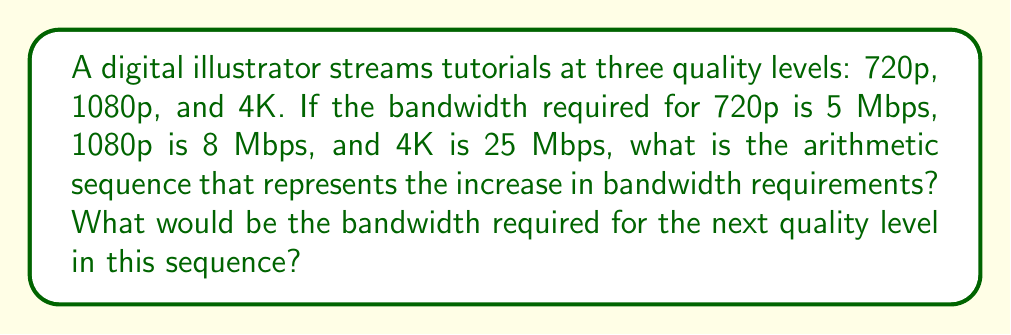Can you solve this math problem? 1. First, let's identify the given bandwidth requirements:
   720p: 5 Mbps
   1080p: 8 Mbps
   4K: 25 Mbps

2. To determine if this is an arithmetic sequence, we need to calculate the differences between consecutive terms:
   $8 - 5 = 3$ Mbps (difference between 1080p and 720p)
   $25 - 8 = 17$ Mbps (difference between 4K and 1080p)

3. Since the differences are not constant, this is not a simple arithmetic sequence. However, we can observe that the differences form an arithmetic sequence:
   $3, 17, ...$

4. To find the common difference of this new sequence:
   $17 - 3 = 14$

5. So, the sequence of differences is: $3, 17, 31, ...$
   Where the next term would be $17 + 14 = 31$

6. Now, we can represent the original bandwidth sequence as:
   $a_n = a_1 + (3 + 14(n-2))$ for $n \geq 2$
   Where $a_1 = 5$ (the first term)

7. To find the next term in the original sequence:
   $a_4 = 5 + (3 + 17 + 31)$
   $a_4 = 5 + 51 = 56$ Mbps

Therefore, the bandwidth required for the next quality level would be 56 Mbps.
Answer: $a_n = 5 + (3 + 14(n-2))$ for $n \geq 2$; Next level: 56 Mbps 